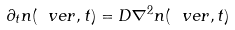<formula> <loc_0><loc_0><loc_500><loc_500>\partial _ { t } n ( \ v e r , t ) = D \nabla ^ { 2 } n ( \ v e r , t )</formula> 